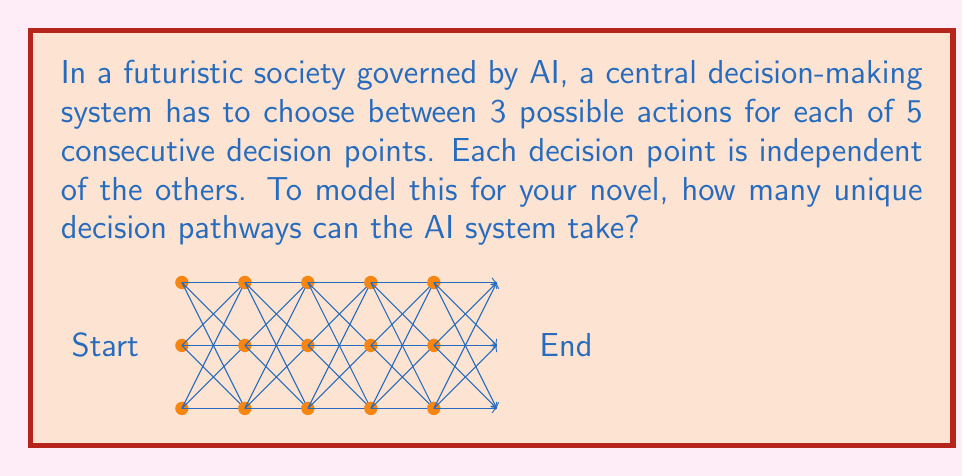Give your solution to this math problem. To solve this problem, we can use the multiplication principle of combinatorics:

1) At each decision point, the AI has 3 possible actions to choose from.

2) There are 5 consecutive decision points.

3) The choices at each point are independent of the others.

4) According to the multiplication principle, if we have $n$ independent events, and each event $i$ has $m_i$ possible outcomes, then the total number of possible outcomes for all events is:

   $$\prod_{i=1}^n m_i$$

5) In this case, we have 5 events (decision points), each with 3 possible outcomes.

6) Therefore, the total number of possible pathways is:

   $$3 \times 3 \times 3 \times 3 \times 3 = 3^5$$

7) Calculating this:

   $$3^5 = 3 \times 3 \times 3 \times 3 \times 3 = 243$$

Thus, there are 243 unique decision pathways that the AI system can take.
Answer: $3^5 = 243$ 